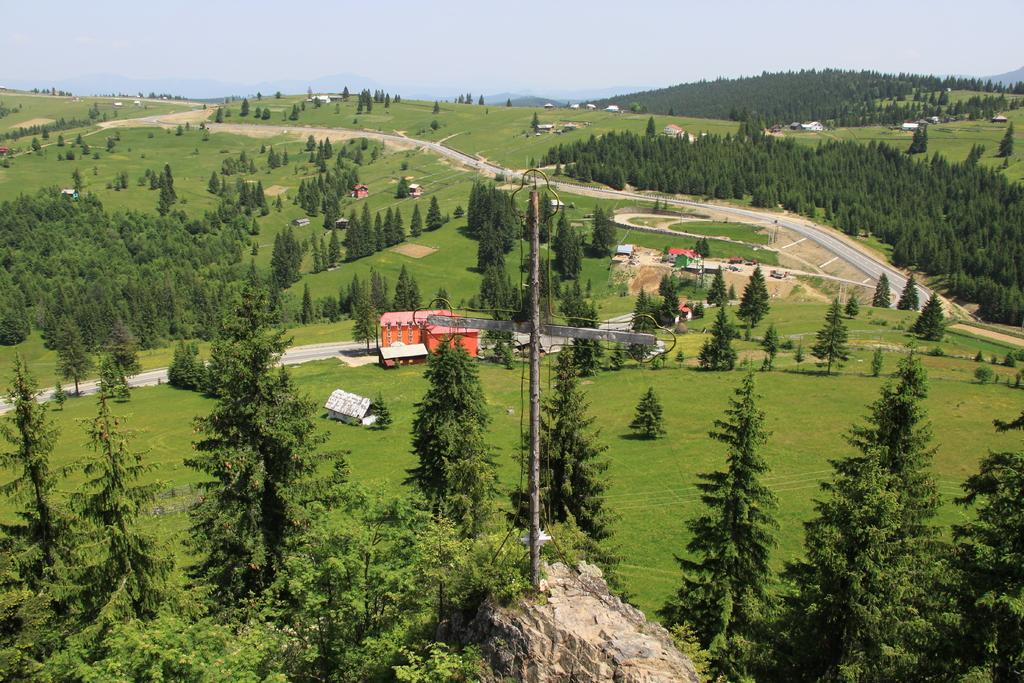What can be seen in the sky in the image? There is sky visible in the image. What type of natural features are present in the image? There are hills and valleys in the image. What type of vegetation is present in the image? There are trees in the image. What type of man-made structures are present in the image? There are buildings and poles in the image. What is the terrain like in the image? The terrain includes hills, valleys, and a road. What other natural object is present in the image? There is a rock in the image. How many visitors are present in the image? There is no mention of visitors in the image. What type of secretary can be seen working in the image? There is no secretary present in the image. 